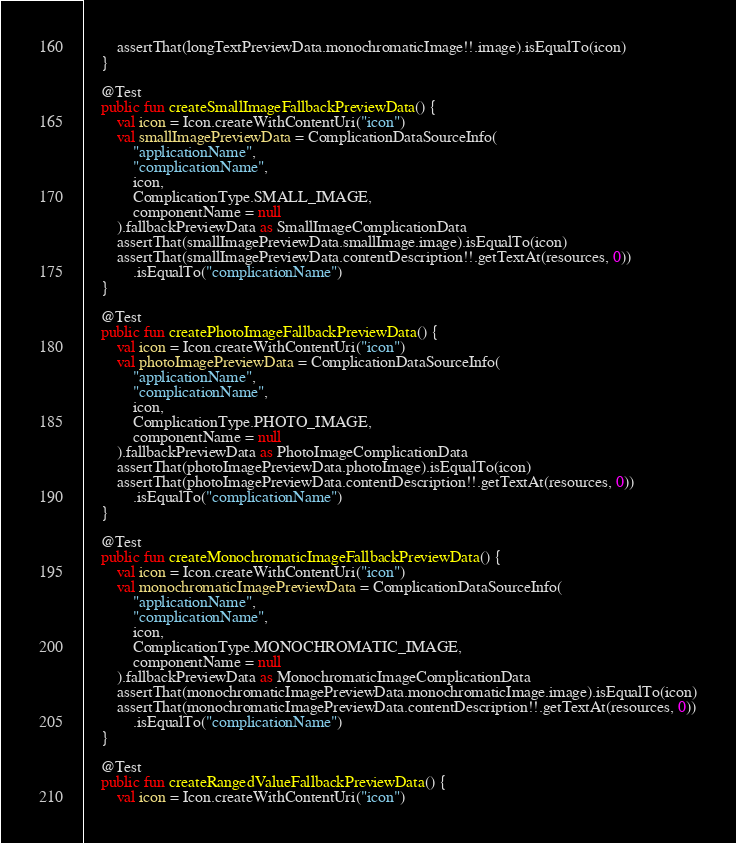Convert code to text. <code><loc_0><loc_0><loc_500><loc_500><_Kotlin_>        assertThat(longTextPreviewData.monochromaticImage!!.image).isEqualTo(icon)
    }

    @Test
    public fun createSmallImageFallbackPreviewData() {
        val icon = Icon.createWithContentUri("icon")
        val smallImagePreviewData = ComplicationDataSourceInfo(
            "applicationName",
            "complicationName",
            icon,
            ComplicationType.SMALL_IMAGE,
            componentName = null
        ).fallbackPreviewData as SmallImageComplicationData
        assertThat(smallImagePreviewData.smallImage.image).isEqualTo(icon)
        assertThat(smallImagePreviewData.contentDescription!!.getTextAt(resources, 0))
            .isEqualTo("complicationName")
    }

    @Test
    public fun createPhotoImageFallbackPreviewData() {
        val icon = Icon.createWithContentUri("icon")
        val photoImagePreviewData = ComplicationDataSourceInfo(
            "applicationName",
            "complicationName",
            icon,
            ComplicationType.PHOTO_IMAGE,
            componentName = null
        ).fallbackPreviewData as PhotoImageComplicationData
        assertThat(photoImagePreviewData.photoImage).isEqualTo(icon)
        assertThat(photoImagePreviewData.contentDescription!!.getTextAt(resources, 0))
            .isEqualTo("complicationName")
    }

    @Test
    public fun createMonochromaticImageFallbackPreviewData() {
        val icon = Icon.createWithContentUri("icon")
        val monochromaticImagePreviewData = ComplicationDataSourceInfo(
            "applicationName",
            "complicationName",
            icon,
            ComplicationType.MONOCHROMATIC_IMAGE,
            componentName = null
        ).fallbackPreviewData as MonochromaticImageComplicationData
        assertThat(monochromaticImagePreviewData.monochromaticImage.image).isEqualTo(icon)
        assertThat(monochromaticImagePreviewData.contentDescription!!.getTextAt(resources, 0))
            .isEqualTo("complicationName")
    }

    @Test
    public fun createRangedValueFallbackPreviewData() {
        val icon = Icon.createWithContentUri("icon")</code> 